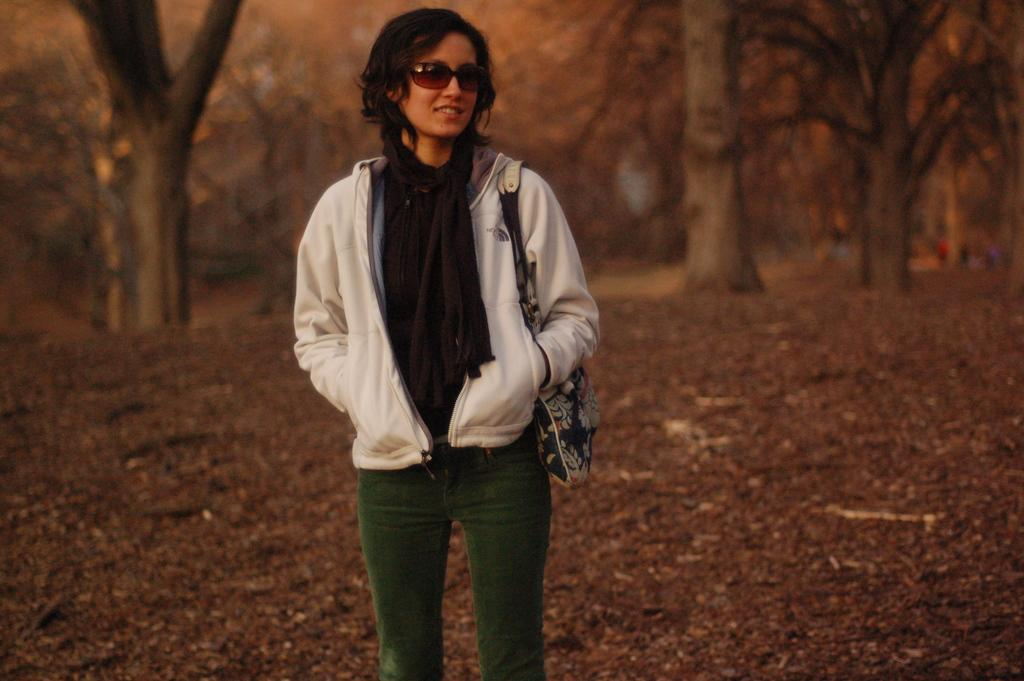What is the primary subject of the image? There is a woman in the image. What is the woman doing in the image? The woman is standing and smiling. What is the woman holding or carrying in the image? The woman is carrying a bag. What can be seen in the background of the image? There are trees in the background of the image. What type of crack can be seen on the woman's face in the image? There is no crack visible on the woman's face in the image. 